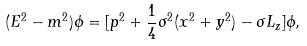Convert formula to latex. <formula><loc_0><loc_0><loc_500><loc_500>( E ^ { 2 } - m ^ { 2 } ) \phi = [ { p } ^ { 2 } + \frac { 1 } { 4 } \sigma ^ { 2 } ( x ^ { 2 } + y ^ { 2 } ) - \sigma L _ { z } ] \phi ,</formula> 